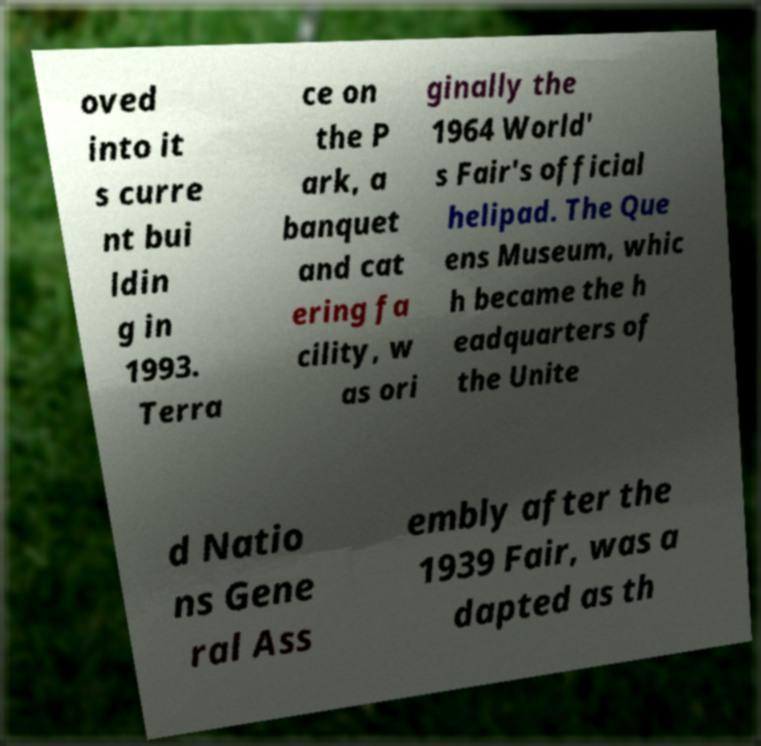Can you accurately transcribe the text from the provided image for me? oved into it s curre nt bui ldin g in 1993. Terra ce on the P ark, a banquet and cat ering fa cility, w as ori ginally the 1964 World' s Fair's official helipad. The Que ens Museum, whic h became the h eadquarters of the Unite d Natio ns Gene ral Ass embly after the 1939 Fair, was a dapted as th 